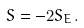Convert formula to latex. <formula><loc_0><loc_0><loc_500><loc_500>S = - 2 S _ { E } .</formula> 